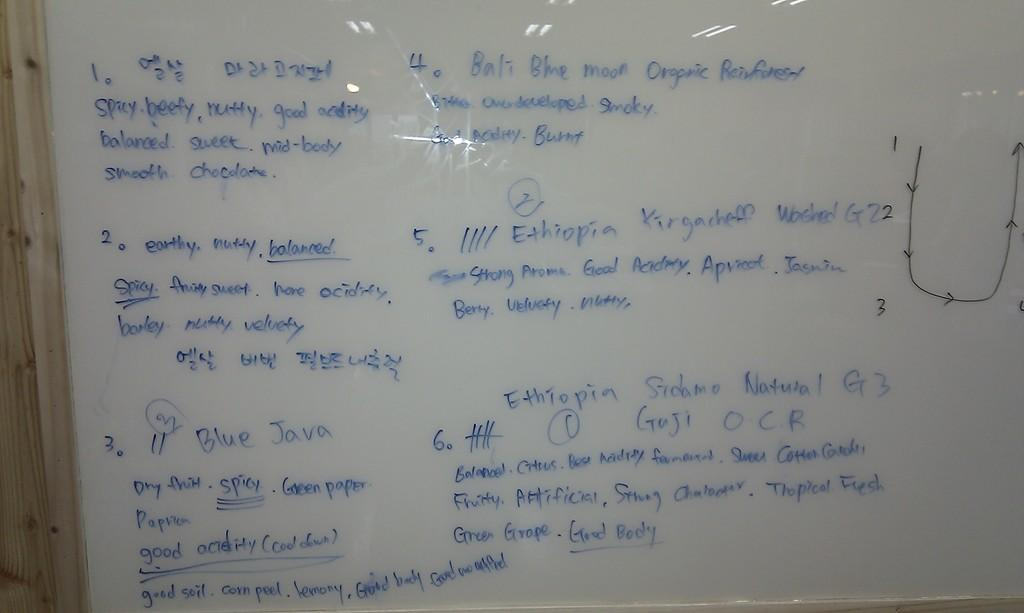Provide a one-sentence caption for the provided image. A whiteboard with blue writing describes a coffee as spicy, beefy and nutty. 